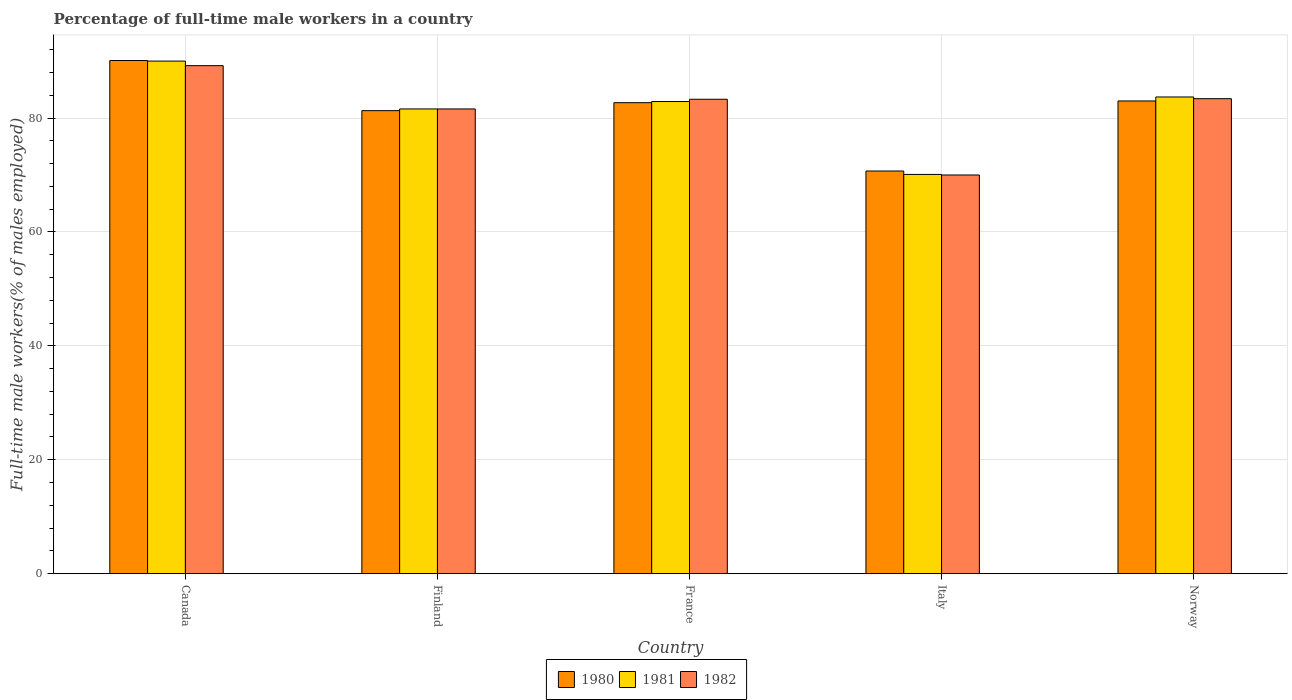Are the number of bars per tick equal to the number of legend labels?
Your response must be concise. Yes. How many bars are there on the 5th tick from the left?
Provide a short and direct response. 3. How many bars are there on the 4th tick from the right?
Provide a succinct answer. 3. In how many cases, is the number of bars for a given country not equal to the number of legend labels?
Ensure brevity in your answer.  0. What is the percentage of full-time male workers in 1982 in Finland?
Your answer should be very brief. 81.6. Across all countries, what is the maximum percentage of full-time male workers in 1982?
Offer a very short reply. 89.2. In which country was the percentage of full-time male workers in 1982 maximum?
Provide a short and direct response. Canada. What is the total percentage of full-time male workers in 1982 in the graph?
Provide a succinct answer. 407.5. What is the difference between the percentage of full-time male workers in 1980 in Canada and that in Finland?
Offer a terse response. 8.8. What is the average percentage of full-time male workers in 1981 per country?
Give a very brief answer. 81.66. What is the difference between the percentage of full-time male workers of/in 1980 and percentage of full-time male workers of/in 1981 in Norway?
Provide a short and direct response. -0.7. What is the ratio of the percentage of full-time male workers in 1982 in Finland to that in France?
Provide a succinct answer. 0.98. Is the percentage of full-time male workers in 1980 in Finland less than that in France?
Provide a succinct answer. Yes. What is the difference between the highest and the second highest percentage of full-time male workers in 1981?
Ensure brevity in your answer.  6.3. What is the difference between the highest and the lowest percentage of full-time male workers in 1982?
Offer a very short reply. 19.2. In how many countries, is the percentage of full-time male workers in 1980 greater than the average percentage of full-time male workers in 1980 taken over all countries?
Your answer should be compact. 3. Is the sum of the percentage of full-time male workers in 1982 in Finland and France greater than the maximum percentage of full-time male workers in 1981 across all countries?
Give a very brief answer. Yes. What does the 3rd bar from the right in Finland represents?
Make the answer very short. 1980. Is it the case that in every country, the sum of the percentage of full-time male workers in 1982 and percentage of full-time male workers in 1981 is greater than the percentage of full-time male workers in 1980?
Your response must be concise. Yes. How many bars are there?
Make the answer very short. 15. Are the values on the major ticks of Y-axis written in scientific E-notation?
Your answer should be compact. No. Does the graph contain grids?
Give a very brief answer. Yes. Where does the legend appear in the graph?
Offer a very short reply. Bottom center. What is the title of the graph?
Provide a succinct answer. Percentage of full-time male workers in a country. Does "1982" appear as one of the legend labels in the graph?
Offer a very short reply. Yes. What is the label or title of the X-axis?
Provide a short and direct response. Country. What is the label or title of the Y-axis?
Offer a terse response. Full-time male workers(% of males employed). What is the Full-time male workers(% of males employed) in 1980 in Canada?
Provide a short and direct response. 90.1. What is the Full-time male workers(% of males employed) in 1982 in Canada?
Offer a very short reply. 89.2. What is the Full-time male workers(% of males employed) of 1980 in Finland?
Your answer should be very brief. 81.3. What is the Full-time male workers(% of males employed) in 1981 in Finland?
Offer a very short reply. 81.6. What is the Full-time male workers(% of males employed) of 1982 in Finland?
Offer a very short reply. 81.6. What is the Full-time male workers(% of males employed) of 1980 in France?
Ensure brevity in your answer.  82.7. What is the Full-time male workers(% of males employed) of 1981 in France?
Provide a short and direct response. 82.9. What is the Full-time male workers(% of males employed) of 1982 in France?
Keep it short and to the point. 83.3. What is the Full-time male workers(% of males employed) in 1980 in Italy?
Keep it short and to the point. 70.7. What is the Full-time male workers(% of males employed) in 1981 in Italy?
Your answer should be compact. 70.1. What is the Full-time male workers(% of males employed) of 1982 in Italy?
Provide a succinct answer. 70. What is the Full-time male workers(% of males employed) in 1981 in Norway?
Make the answer very short. 83.7. What is the Full-time male workers(% of males employed) of 1982 in Norway?
Keep it short and to the point. 83.4. Across all countries, what is the maximum Full-time male workers(% of males employed) in 1980?
Your response must be concise. 90.1. Across all countries, what is the maximum Full-time male workers(% of males employed) of 1982?
Offer a terse response. 89.2. Across all countries, what is the minimum Full-time male workers(% of males employed) in 1980?
Keep it short and to the point. 70.7. Across all countries, what is the minimum Full-time male workers(% of males employed) in 1981?
Offer a very short reply. 70.1. Across all countries, what is the minimum Full-time male workers(% of males employed) in 1982?
Ensure brevity in your answer.  70. What is the total Full-time male workers(% of males employed) in 1980 in the graph?
Offer a very short reply. 407.8. What is the total Full-time male workers(% of males employed) of 1981 in the graph?
Provide a succinct answer. 408.3. What is the total Full-time male workers(% of males employed) in 1982 in the graph?
Your answer should be very brief. 407.5. What is the difference between the Full-time male workers(% of males employed) in 1980 in Canada and that in Finland?
Offer a terse response. 8.8. What is the difference between the Full-time male workers(% of males employed) of 1981 in Canada and that in Finland?
Your answer should be very brief. 8.4. What is the difference between the Full-time male workers(% of males employed) of 1981 in Canada and that in France?
Provide a short and direct response. 7.1. What is the difference between the Full-time male workers(% of males employed) of 1982 in Canada and that in France?
Your response must be concise. 5.9. What is the difference between the Full-time male workers(% of males employed) of 1980 in Canada and that in Italy?
Provide a succinct answer. 19.4. What is the difference between the Full-time male workers(% of males employed) in 1981 in Canada and that in Italy?
Keep it short and to the point. 19.9. What is the difference between the Full-time male workers(% of males employed) in 1980 in Finland and that in France?
Your answer should be very brief. -1.4. What is the difference between the Full-time male workers(% of males employed) of 1981 in Finland and that in France?
Keep it short and to the point. -1.3. What is the difference between the Full-time male workers(% of males employed) in 1980 in Finland and that in Italy?
Your answer should be very brief. 10.6. What is the difference between the Full-time male workers(% of males employed) in 1982 in Finland and that in Italy?
Offer a terse response. 11.6. What is the difference between the Full-time male workers(% of males employed) of 1982 in Finland and that in Norway?
Your answer should be very brief. -1.8. What is the difference between the Full-time male workers(% of males employed) of 1981 in France and that in Italy?
Your answer should be very brief. 12.8. What is the difference between the Full-time male workers(% of males employed) of 1980 in France and that in Norway?
Your answer should be very brief. -0.3. What is the difference between the Full-time male workers(% of males employed) in 1981 in France and that in Norway?
Provide a succinct answer. -0.8. What is the difference between the Full-time male workers(% of males employed) in 1982 in France and that in Norway?
Provide a short and direct response. -0.1. What is the difference between the Full-time male workers(% of males employed) in 1982 in Italy and that in Norway?
Ensure brevity in your answer.  -13.4. What is the difference between the Full-time male workers(% of males employed) in 1980 in Canada and the Full-time male workers(% of males employed) in 1981 in Finland?
Make the answer very short. 8.5. What is the difference between the Full-time male workers(% of males employed) in 1980 in Canada and the Full-time male workers(% of males employed) in 1982 in Finland?
Provide a short and direct response. 8.5. What is the difference between the Full-time male workers(% of males employed) of 1981 in Canada and the Full-time male workers(% of males employed) of 1982 in Finland?
Provide a succinct answer. 8.4. What is the difference between the Full-time male workers(% of males employed) of 1980 in Canada and the Full-time male workers(% of males employed) of 1981 in France?
Your answer should be compact. 7.2. What is the difference between the Full-time male workers(% of males employed) of 1980 in Canada and the Full-time male workers(% of males employed) of 1982 in France?
Ensure brevity in your answer.  6.8. What is the difference between the Full-time male workers(% of males employed) of 1981 in Canada and the Full-time male workers(% of males employed) of 1982 in France?
Your answer should be very brief. 6.7. What is the difference between the Full-time male workers(% of males employed) of 1980 in Canada and the Full-time male workers(% of males employed) of 1982 in Italy?
Your answer should be compact. 20.1. What is the difference between the Full-time male workers(% of males employed) in 1980 in Canada and the Full-time male workers(% of males employed) in 1982 in Norway?
Give a very brief answer. 6.7. What is the difference between the Full-time male workers(% of males employed) in 1981 in Canada and the Full-time male workers(% of males employed) in 1982 in Norway?
Provide a succinct answer. 6.6. What is the difference between the Full-time male workers(% of males employed) of 1980 in Finland and the Full-time male workers(% of males employed) of 1981 in Italy?
Give a very brief answer. 11.2. What is the difference between the Full-time male workers(% of males employed) in 1980 in Finland and the Full-time male workers(% of males employed) in 1982 in Italy?
Offer a very short reply. 11.3. What is the difference between the Full-time male workers(% of males employed) of 1981 in Finland and the Full-time male workers(% of males employed) of 1982 in Italy?
Provide a short and direct response. 11.6. What is the difference between the Full-time male workers(% of males employed) of 1980 in Finland and the Full-time male workers(% of males employed) of 1981 in Norway?
Give a very brief answer. -2.4. What is the difference between the Full-time male workers(% of males employed) in 1980 in Finland and the Full-time male workers(% of males employed) in 1982 in Norway?
Keep it short and to the point. -2.1. What is the difference between the Full-time male workers(% of males employed) in 1981 in Finland and the Full-time male workers(% of males employed) in 1982 in Norway?
Provide a short and direct response. -1.8. What is the difference between the Full-time male workers(% of males employed) of 1980 in France and the Full-time male workers(% of males employed) of 1981 in Italy?
Give a very brief answer. 12.6. What is the difference between the Full-time male workers(% of males employed) of 1981 in France and the Full-time male workers(% of males employed) of 1982 in Italy?
Make the answer very short. 12.9. What is the difference between the Full-time male workers(% of males employed) of 1981 in France and the Full-time male workers(% of males employed) of 1982 in Norway?
Keep it short and to the point. -0.5. What is the difference between the Full-time male workers(% of males employed) of 1980 in Italy and the Full-time male workers(% of males employed) of 1982 in Norway?
Provide a short and direct response. -12.7. What is the average Full-time male workers(% of males employed) in 1980 per country?
Your answer should be compact. 81.56. What is the average Full-time male workers(% of males employed) in 1981 per country?
Your answer should be compact. 81.66. What is the average Full-time male workers(% of males employed) in 1982 per country?
Provide a succinct answer. 81.5. What is the difference between the Full-time male workers(% of males employed) in 1980 and Full-time male workers(% of males employed) in 1982 in Canada?
Make the answer very short. 0.9. What is the difference between the Full-time male workers(% of males employed) of 1981 and Full-time male workers(% of males employed) of 1982 in Canada?
Keep it short and to the point. 0.8. What is the difference between the Full-time male workers(% of males employed) of 1980 and Full-time male workers(% of males employed) of 1981 in Finland?
Your answer should be very brief. -0.3. What is the difference between the Full-time male workers(% of males employed) of 1980 and Full-time male workers(% of males employed) of 1982 in Finland?
Make the answer very short. -0.3. What is the difference between the Full-time male workers(% of males employed) in 1980 and Full-time male workers(% of males employed) in 1981 in France?
Keep it short and to the point. -0.2. What is the difference between the Full-time male workers(% of males employed) in 1980 and Full-time male workers(% of males employed) in 1982 in France?
Provide a short and direct response. -0.6. What is the difference between the Full-time male workers(% of males employed) of 1980 and Full-time male workers(% of males employed) of 1982 in Italy?
Give a very brief answer. 0.7. What is the difference between the Full-time male workers(% of males employed) in 1981 and Full-time male workers(% of males employed) in 1982 in Italy?
Offer a terse response. 0.1. What is the difference between the Full-time male workers(% of males employed) of 1981 and Full-time male workers(% of males employed) of 1982 in Norway?
Offer a terse response. 0.3. What is the ratio of the Full-time male workers(% of males employed) in 1980 in Canada to that in Finland?
Your answer should be very brief. 1.11. What is the ratio of the Full-time male workers(% of males employed) in 1981 in Canada to that in Finland?
Give a very brief answer. 1.1. What is the ratio of the Full-time male workers(% of males employed) of 1982 in Canada to that in Finland?
Offer a terse response. 1.09. What is the ratio of the Full-time male workers(% of males employed) of 1980 in Canada to that in France?
Keep it short and to the point. 1.09. What is the ratio of the Full-time male workers(% of males employed) of 1981 in Canada to that in France?
Provide a short and direct response. 1.09. What is the ratio of the Full-time male workers(% of males employed) of 1982 in Canada to that in France?
Make the answer very short. 1.07. What is the ratio of the Full-time male workers(% of males employed) of 1980 in Canada to that in Italy?
Your answer should be very brief. 1.27. What is the ratio of the Full-time male workers(% of males employed) of 1981 in Canada to that in Italy?
Offer a very short reply. 1.28. What is the ratio of the Full-time male workers(% of males employed) in 1982 in Canada to that in Italy?
Your answer should be compact. 1.27. What is the ratio of the Full-time male workers(% of males employed) in 1980 in Canada to that in Norway?
Ensure brevity in your answer.  1.09. What is the ratio of the Full-time male workers(% of males employed) in 1981 in Canada to that in Norway?
Your answer should be compact. 1.08. What is the ratio of the Full-time male workers(% of males employed) of 1982 in Canada to that in Norway?
Your response must be concise. 1.07. What is the ratio of the Full-time male workers(% of males employed) of 1980 in Finland to that in France?
Provide a succinct answer. 0.98. What is the ratio of the Full-time male workers(% of males employed) of 1981 in Finland to that in France?
Your answer should be very brief. 0.98. What is the ratio of the Full-time male workers(% of males employed) in 1982 in Finland to that in France?
Your answer should be very brief. 0.98. What is the ratio of the Full-time male workers(% of males employed) of 1980 in Finland to that in Italy?
Provide a succinct answer. 1.15. What is the ratio of the Full-time male workers(% of males employed) in 1981 in Finland to that in Italy?
Offer a very short reply. 1.16. What is the ratio of the Full-time male workers(% of males employed) of 1982 in Finland to that in Italy?
Keep it short and to the point. 1.17. What is the ratio of the Full-time male workers(% of males employed) in 1980 in Finland to that in Norway?
Provide a succinct answer. 0.98. What is the ratio of the Full-time male workers(% of males employed) of 1981 in Finland to that in Norway?
Your response must be concise. 0.97. What is the ratio of the Full-time male workers(% of males employed) in 1982 in Finland to that in Norway?
Your response must be concise. 0.98. What is the ratio of the Full-time male workers(% of males employed) in 1980 in France to that in Italy?
Ensure brevity in your answer.  1.17. What is the ratio of the Full-time male workers(% of males employed) of 1981 in France to that in Italy?
Provide a short and direct response. 1.18. What is the ratio of the Full-time male workers(% of males employed) of 1982 in France to that in Italy?
Make the answer very short. 1.19. What is the ratio of the Full-time male workers(% of males employed) in 1980 in France to that in Norway?
Your response must be concise. 1. What is the ratio of the Full-time male workers(% of males employed) of 1981 in France to that in Norway?
Provide a short and direct response. 0.99. What is the ratio of the Full-time male workers(% of males employed) in 1982 in France to that in Norway?
Provide a succinct answer. 1. What is the ratio of the Full-time male workers(% of males employed) in 1980 in Italy to that in Norway?
Make the answer very short. 0.85. What is the ratio of the Full-time male workers(% of males employed) in 1981 in Italy to that in Norway?
Offer a terse response. 0.84. What is the ratio of the Full-time male workers(% of males employed) of 1982 in Italy to that in Norway?
Your answer should be very brief. 0.84. What is the difference between the highest and the second highest Full-time male workers(% of males employed) of 1981?
Offer a terse response. 6.3. What is the difference between the highest and the lowest Full-time male workers(% of males employed) of 1981?
Provide a succinct answer. 19.9. 